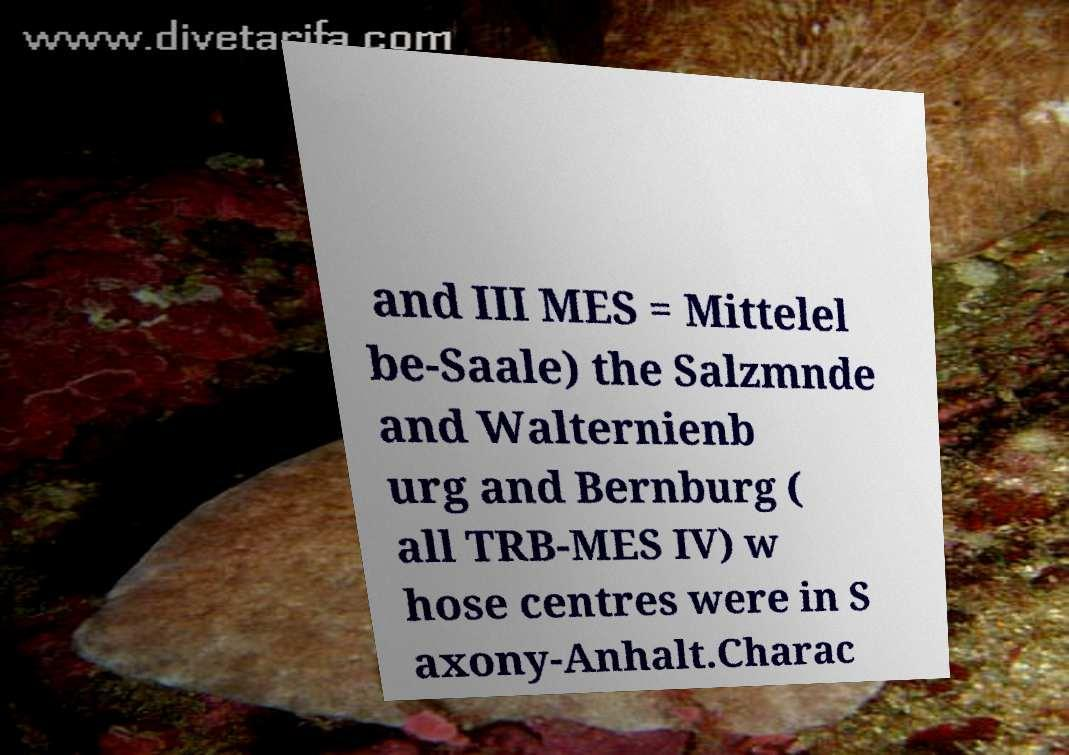There's text embedded in this image that I need extracted. Can you transcribe it verbatim? and III MES = Mittelel be-Saale) the Salzmnde and Walternienb urg and Bernburg ( all TRB-MES IV) w hose centres were in S axony-Anhalt.Charac 